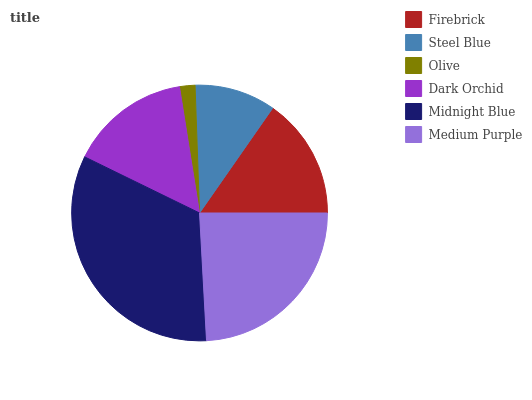Is Olive the minimum?
Answer yes or no. Yes. Is Midnight Blue the maximum?
Answer yes or no. Yes. Is Steel Blue the minimum?
Answer yes or no. No. Is Steel Blue the maximum?
Answer yes or no. No. Is Firebrick greater than Steel Blue?
Answer yes or no. Yes. Is Steel Blue less than Firebrick?
Answer yes or no. Yes. Is Steel Blue greater than Firebrick?
Answer yes or no. No. Is Firebrick less than Steel Blue?
Answer yes or no. No. Is Firebrick the high median?
Answer yes or no. Yes. Is Dark Orchid the low median?
Answer yes or no. Yes. Is Steel Blue the high median?
Answer yes or no. No. Is Midnight Blue the low median?
Answer yes or no. No. 